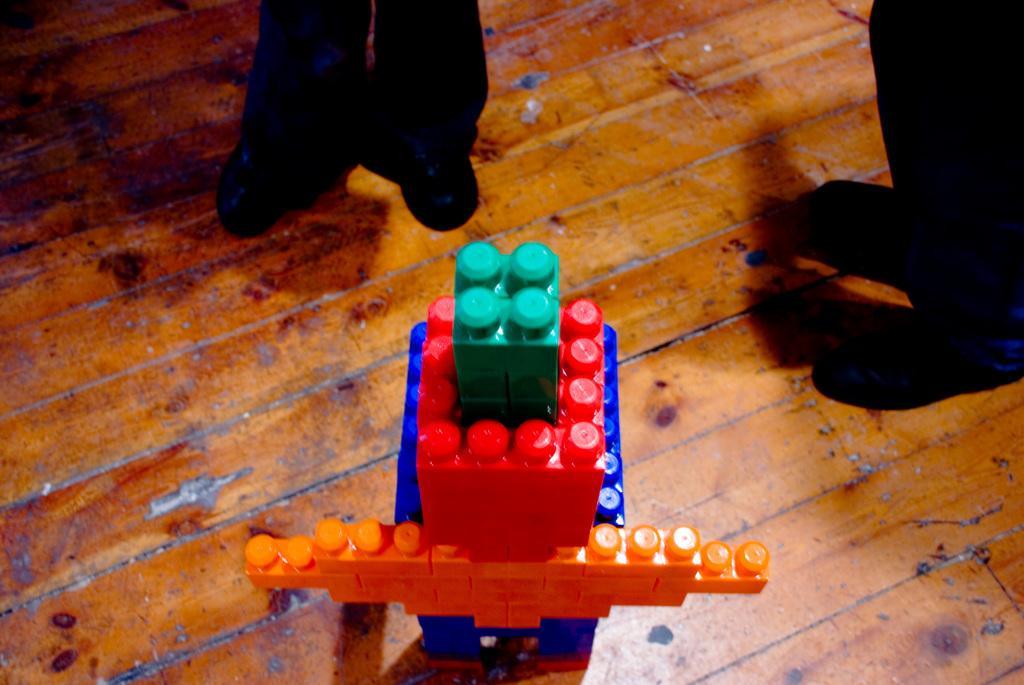Could you give a brief overview of what you see in this image? In this image I can see the brown colored floor and on it I can see a structure which is made with lego. I can see legs of two persons which are black in color. 